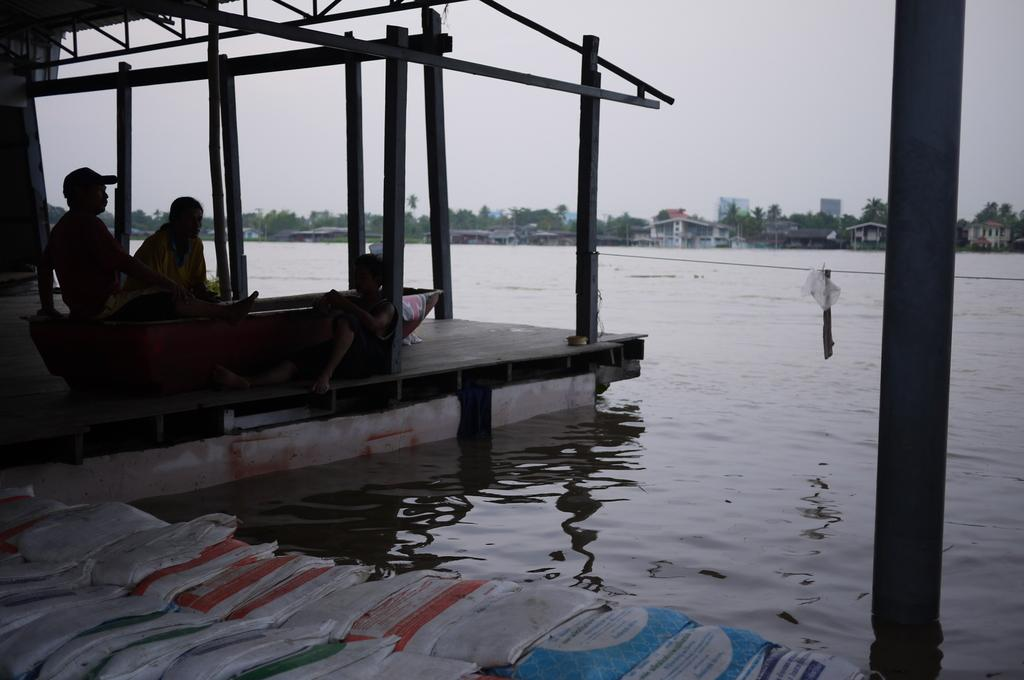What is the primary element in the image? There is water in the image. What are the people in the image doing? There are three people sitting on the surface of the water. What can be seen in the background of the image? There are buildings and trees in the background of the image. What is visible in the sky? There are clouds visible in the sky. What type of reward can be seen hanging from the trees in the image? There is no reward hanging from the trees in the image; it features water, people, buildings, trees, and clouds. How many chairs are visible in the image? There are no chairs present in the image. 